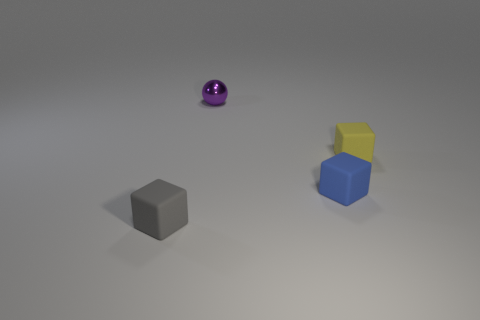Could you infer what the purpose of these objects might be in this setting? Without additional context, it's challenging to determine a specific purpose. However, the objects might be part of a simple color and shape learning set for educational purposes, or they could be basic props in a visual composition meant to express ideas in art or a photographic study. 